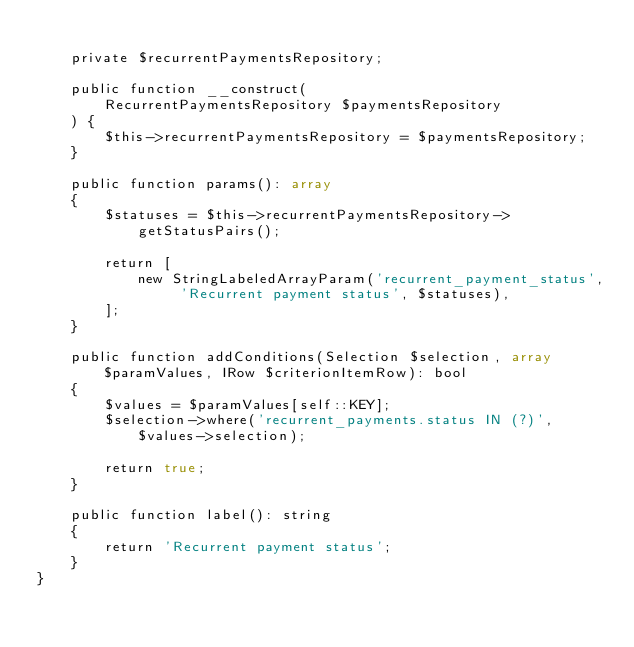Convert code to text. <code><loc_0><loc_0><loc_500><loc_500><_PHP_>
    private $recurrentPaymentsRepository;

    public function __construct(
        RecurrentPaymentsRepository $paymentsRepository
    ) {
        $this->recurrentPaymentsRepository = $paymentsRepository;
    }

    public function params(): array
    {
        $statuses = $this->recurrentPaymentsRepository->getStatusPairs();

        return [
            new StringLabeledArrayParam('recurrent_payment_status', 'Recurrent payment status', $statuses),
        ];
    }

    public function addConditions(Selection $selection, array $paramValues, IRow $criterionItemRow): bool
    {
        $values = $paramValues[self::KEY];
        $selection->where('recurrent_payments.status IN (?)', $values->selection);

        return true;
    }

    public function label(): string
    {
        return 'Recurrent payment status';
    }
}
</code> 